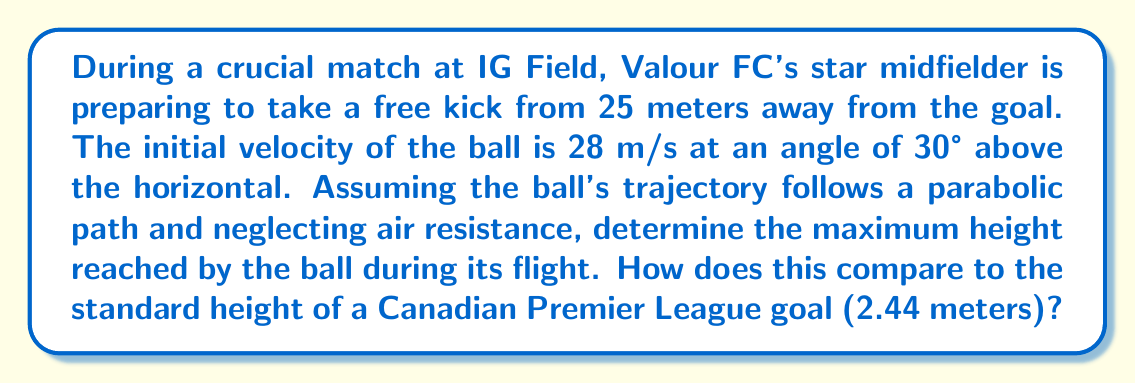Teach me how to tackle this problem. To solve this problem, we'll use the equations of projectile motion, which form a parabolic trajectory. Let's break it down step-by-step:

1) First, we need to identify the relevant equations:
   
   Vertical motion: $y = y_0 + v_0\sin\theta \cdot t - \frac{1}{2}gt^2$
   
   Maximum height occurs when vertical velocity is zero: $v_y = v_0\sin\theta - gt = 0$

2) Given information:
   - Initial velocity, $v_0 = 28$ m/s
   - Angle, $\theta = 30°$
   - Initial height, $y_0 = 0$ m (assuming the kick is taken at ground level)
   - Acceleration due to gravity, $g = 9.8$ m/s²

3) To find the time to reach maximum height:
   
   $v_0\sin\theta - gt = 0$
   $t = \frac{v_0\sin\theta}{g}$
   
   $t = \frac{28 \cdot \sin(30°)}{9.8} = \frac{28 \cdot 0.5}{9.8} = 1.43$ seconds

4) Now we can substitute this time into the vertical motion equation to find the maximum height:

   $y_{max} = y_0 + v_0\sin\theta \cdot t - \frac{1}{2}gt^2$
   
   $y_{max} = 0 + 28\sin(30°) \cdot 1.43 - \frac{1}{2} \cdot 9.8 \cdot 1.43^2$
   
   $y_{max} = 28 \cdot 0.5 \cdot 1.43 - 4.9 \cdot 2.04$
   
   $y_{max} = 20.02 - 10.00 = 10.02$ meters

5) Comparing to the standard goal height:
   
   10.02 meters is approximately 4.11 times higher than the standard goal height of 2.44 meters.
Answer: The maximum height reached by the ball is 10.02 meters, which is about 4.11 times higher than the standard Canadian Premier League goal height of 2.44 meters. 